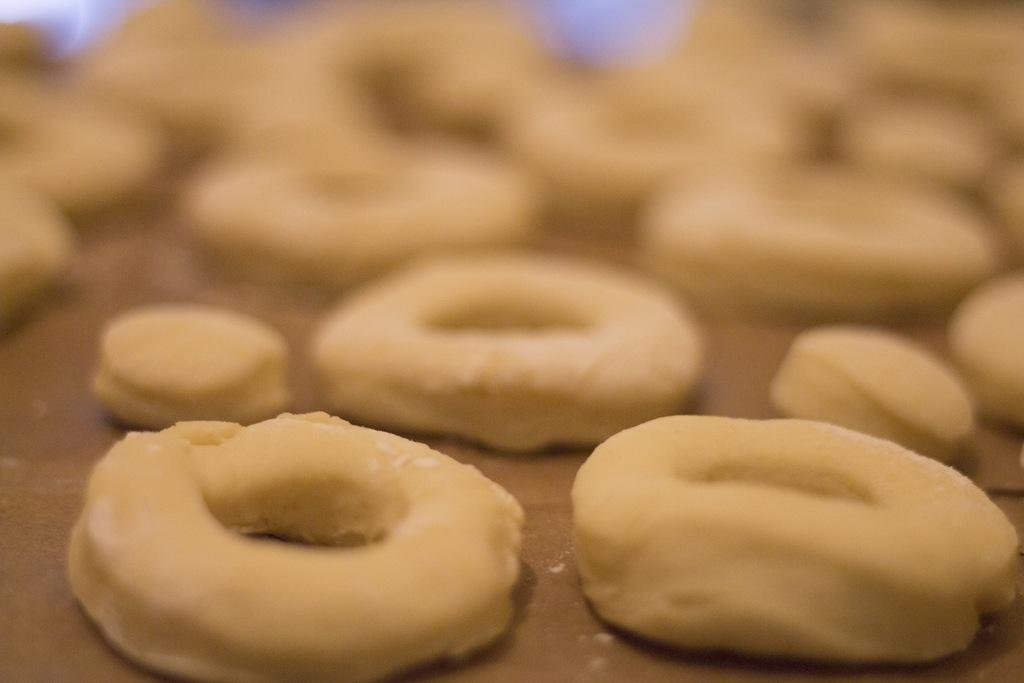What type of food item is visible in the image? There are dough rings in the image. How are the dough rings shaped? The dough rings are in a ring shape. What surface are the dough rings placed on? The dough rings are placed on a wooden plank. What type of kite is visible in the image? There is no kite present in the image; it features dough rings placed on a wooden plank. How many buttons can be seen on the dough rings? There are no buttons present on the dough rings; they are plain ring-shaped dough. 